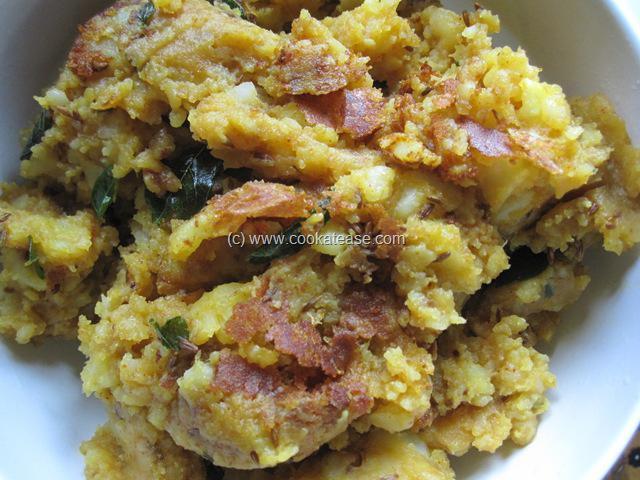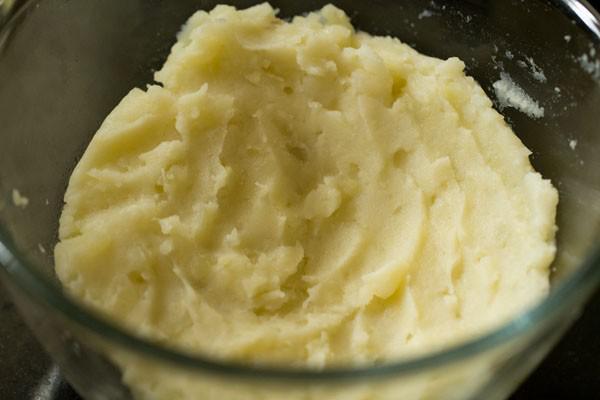The first image is the image on the left, the second image is the image on the right. Considering the images on both sides, is "Mashed potatoes in a black bowl with a ridge design are topped with melted butter and small pieces of chive." valid? Answer yes or no. No. 